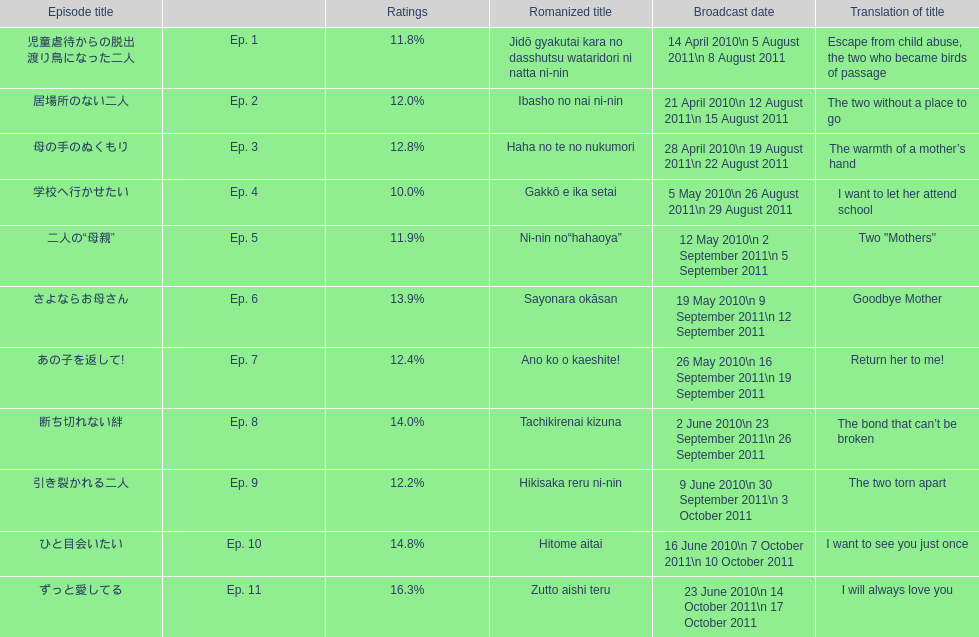Which episode was titled i want to let her attend school? Ep. 4. 